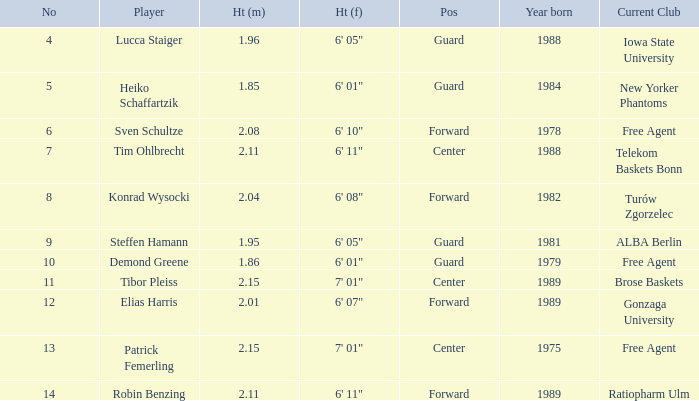Name the height for steffen hamann 6' 05". 